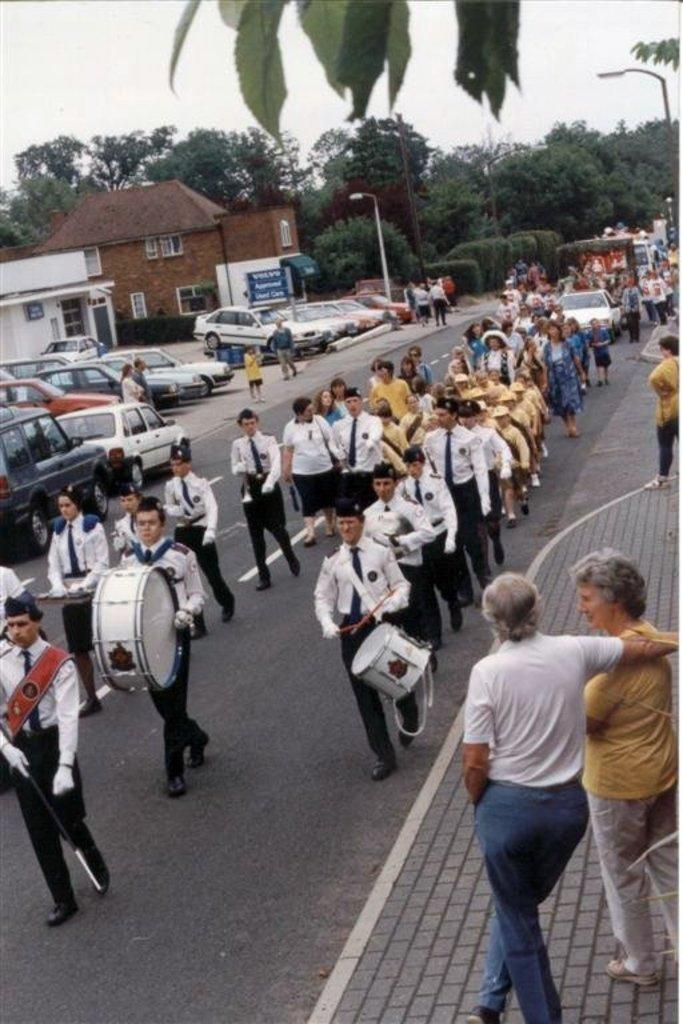What are the people in the image doing? The people in the image are marching in a row. Are there any other people in the image besides the ones marching? Yes, there are spectators in the image. What can be seen in the background of the image? There are cars, buildings, and trees in the background of the image. What type of ring is being taught to the spectators in the image? There is no ring or teaching activity present in the image. 